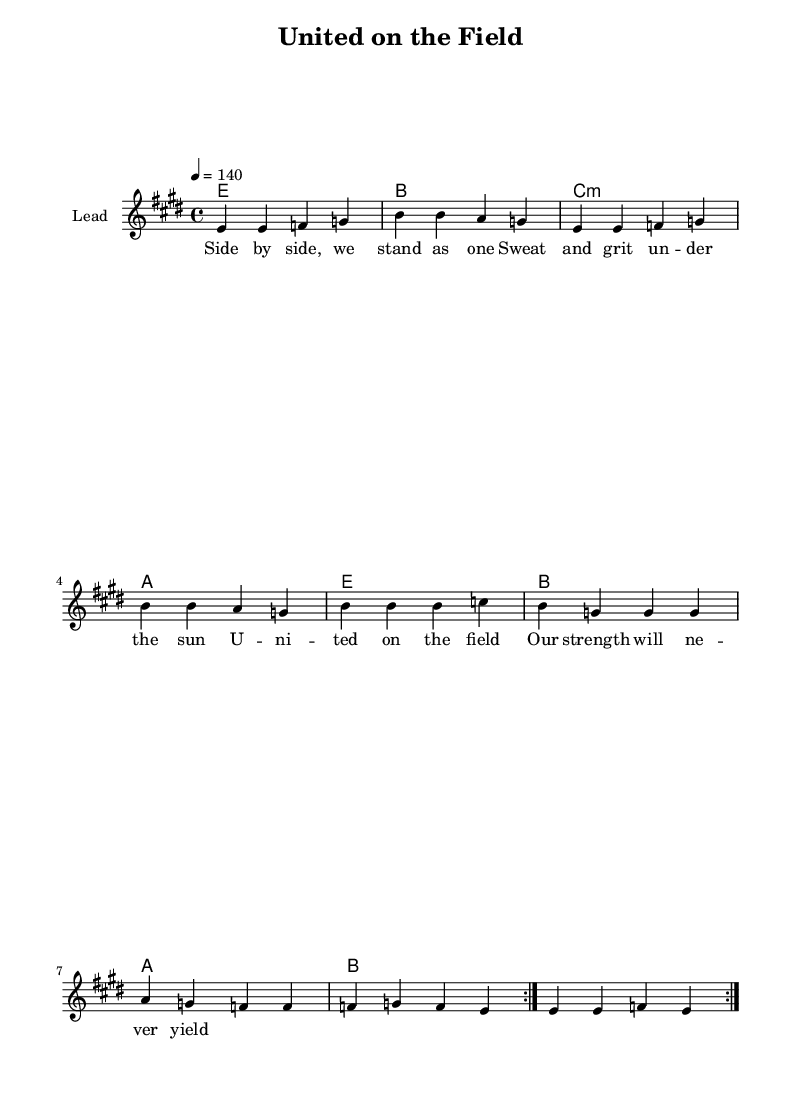What is the key signature of this music? The key signature is E major, which has four sharps. They are F#, C#, G#, and D#.
Answer: E major What is the time signature of this music? The time signature is indicated as 4/4, meaning there are four beats in each measure and the quarter note receives one beat.
Answer: 4/4 What is the tempo marking of this sheet? The tempo is indicated as "4 = 140," meaning that there are 140 beats per minute.
Answer: 140 How many measures are there in the melody section? The melody section consists of eight measures, as indicated by the repetition notation and the layout of notes.
Answer: eight What are the first two notes of the melody? The melody starts with two consecutive E notes, as shown at the beginning of the melody section.
Answer: e e What type of chords are used throughout the harmony? The harmony consists of major and minor chords; specifically, it includes E major, B major, C minor, and A major.
Answer: major and minor What theme does the lyrics emphasize in this music? The lyrics emphasize teamwork and unity, celebrating the bond between individuals on the sports field, as reflected in the chorus.
Answer: teamwork and unity 